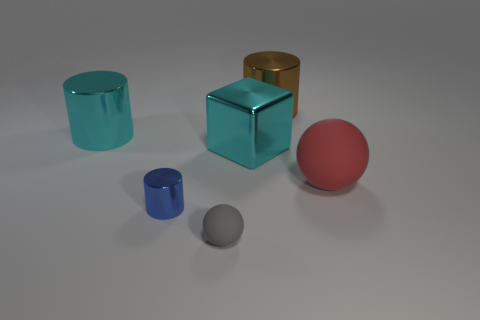What color is the cylinder in front of the cyan object left of the small sphere?
Ensure brevity in your answer.  Blue. How many tiny blue cylinders are there?
Give a very brief answer. 1. Is the number of cylinders to the right of the tiny gray matte object less than the number of metallic objects that are in front of the cyan metal cylinder?
Your answer should be very brief. Yes. The large rubber sphere is what color?
Keep it short and to the point. Red. What number of other metallic cubes are the same color as the cube?
Make the answer very short. 0. There is a brown shiny cylinder; are there any metal cylinders left of it?
Make the answer very short. Yes. Are there the same number of gray things behind the cube and brown cylinders to the left of the gray thing?
Your answer should be compact. Yes. Do the metal thing that is in front of the big red sphere and the shiny cylinder that is on the right side of the small blue cylinder have the same size?
Your response must be concise. No. What shape is the big thing that is behind the big cyan object that is to the left of the matte ball that is left of the red rubber thing?
Make the answer very short. Cylinder. There is another rubber thing that is the same shape as the gray thing; what is its size?
Your response must be concise. Large. 